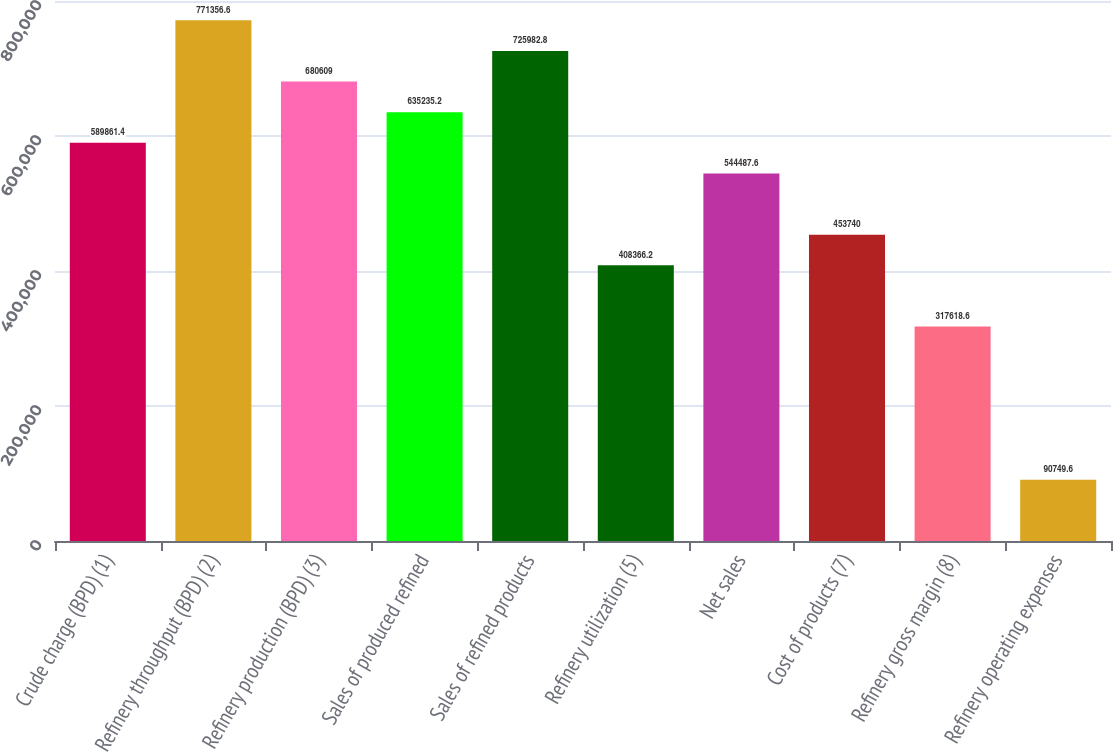Convert chart to OTSL. <chart><loc_0><loc_0><loc_500><loc_500><bar_chart><fcel>Crude charge (BPD) (1)<fcel>Refinery throughput (BPD) (2)<fcel>Refinery production (BPD) (3)<fcel>Sales of produced refined<fcel>Sales of refined products<fcel>Refinery utilization (5)<fcel>Net sales<fcel>Cost of products (7)<fcel>Refinery gross margin (8)<fcel>Refinery operating expenses<nl><fcel>589861<fcel>771357<fcel>680609<fcel>635235<fcel>725983<fcel>408366<fcel>544488<fcel>453740<fcel>317619<fcel>90749.6<nl></chart> 